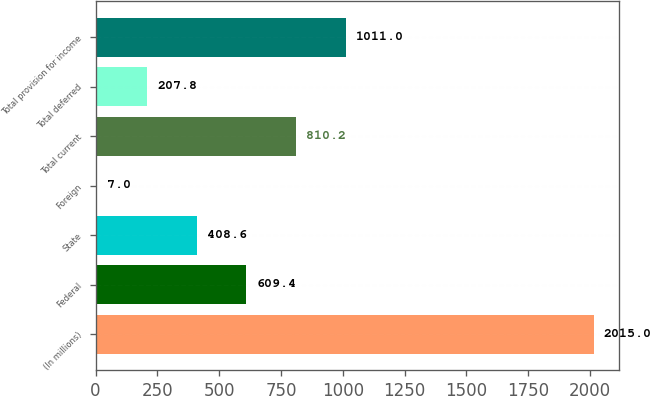<chart> <loc_0><loc_0><loc_500><loc_500><bar_chart><fcel>(In millions)<fcel>Federal<fcel>State<fcel>Foreign<fcel>Total current<fcel>Total deferred<fcel>Total provision for income<nl><fcel>2015<fcel>609.4<fcel>408.6<fcel>7<fcel>810.2<fcel>207.8<fcel>1011<nl></chart> 